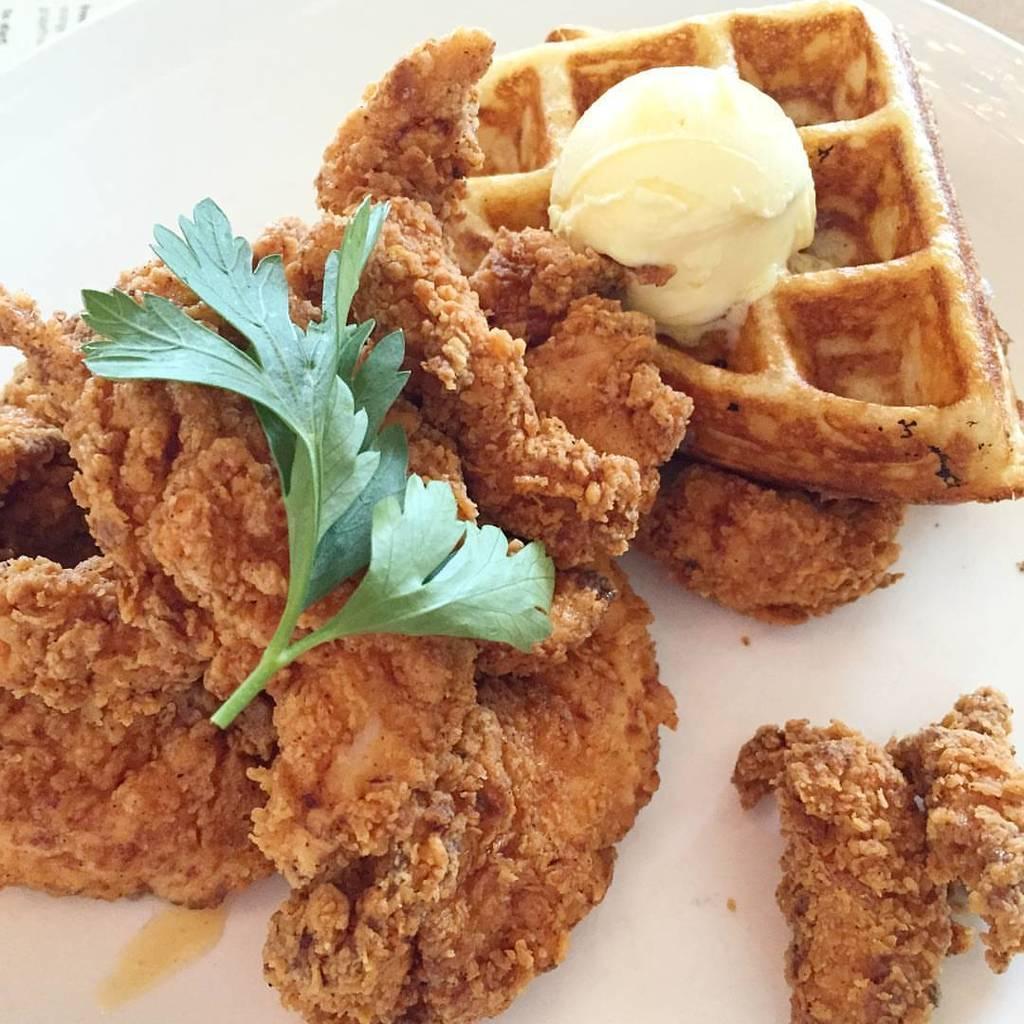Could you give a brief overview of what you see in this image? In the image we can see a plate, in the plate there is food. 